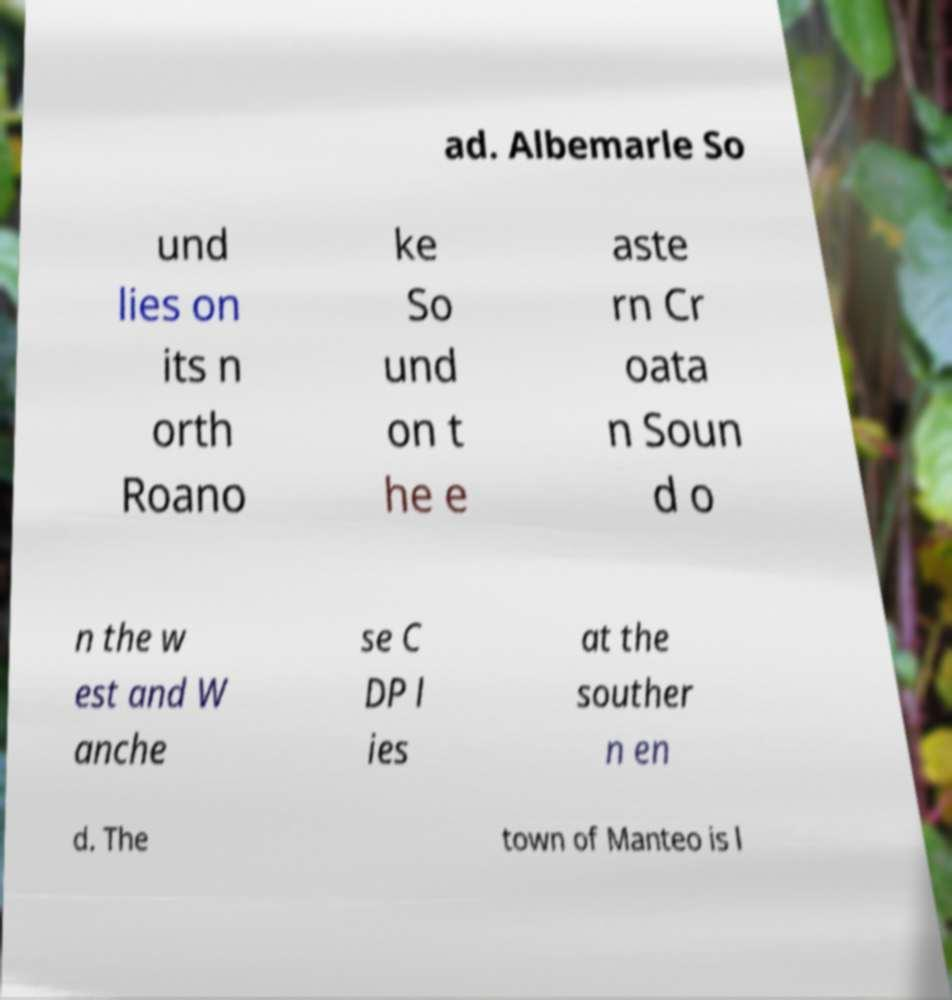Please identify and transcribe the text found in this image. ad. Albemarle So und lies on its n orth Roano ke So und on t he e aste rn Cr oata n Soun d o n the w est and W anche se C DP l ies at the souther n en d. The town of Manteo is l 